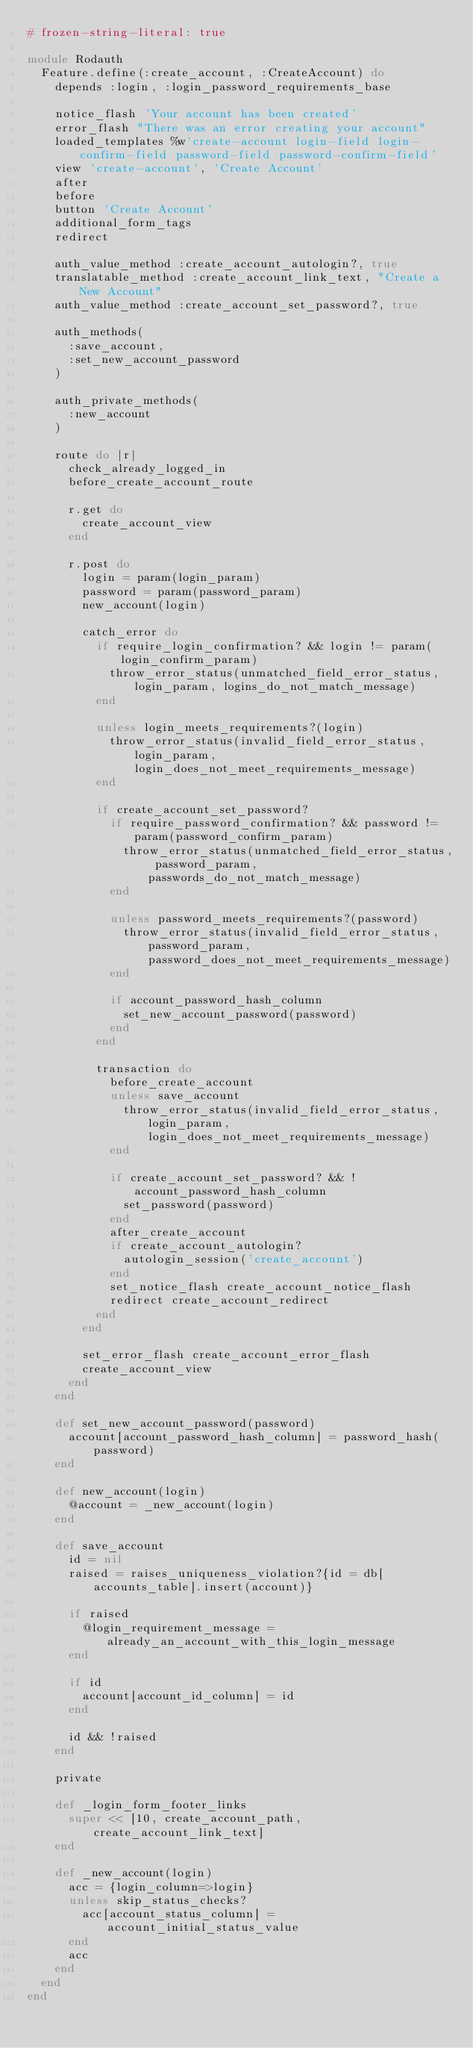Convert code to text. <code><loc_0><loc_0><loc_500><loc_500><_Ruby_># frozen-string-literal: true

module Rodauth
  Feature.define(:create_account, :CreateAccount) do
    depends :login, :login_password_requirements_base

    notice_flash 'Your account has been created'
    error_flash "There was an error creating your account"
    loaded_templates %w'create-account login-field login-confirm-field password-field password-confirm-field'
    view 'create-account', 'Create Account'
    after
    before
    button 'Create Account'
    additional_form_tags
    redirect

    auth_value_method :create_account_autologin?, true
    translatable_method :create_account_link_text, "Create a New Account"
    auth_value_method :create_account_set_password?, true

    auth_methods(
      :save_account,
      :set_new_account_password
    )

    auth_private_methods(
      :new_account
    )

    route do |r|
      check_already_logged_in
      before_create_account_route

      r.get do
        create_account_view
      end

      r.post do
        login = param(login_param)
        password = param(password_param)
        new_account(login)

        catch_error do
          if require_login_confirmation? && login != param(login_confirm_param)
            throw_error_status(unmatched_field_error_status, login_param, logins_do_not_match_message)
          end

          unless login_meets_requirements?(login)
            throw_error_status(invalid_field_error_status, login_param, login_does_not_meet_requirements_message)
          end

          if create_account_set_password?
            if require_password_confirmation? && password != param(password_confirm_param)
              throw_error_status(unmatched_field_error_status, password_param, passwords_do_not_match_message)
            end

            unless password_meets_requirements?(password)
              throw_error_status(invalid_field_error_status, password_param, password_does_not_meet_requirements_message)
            end

            if account_password_hash_column
              set_new_account_password(password)
            end
          end

          transaction do
            before_create_account
            unless save_account
              throw_error_status(invalid_field_error_status, login_param, login_does_not_meet_requirements_message)
            end

            if create_account_set_password? && !account_password_hash_column
              set_password(password)
            end
            after_create_account
            if create_account_autologin?
              autologin_session('create_account')
            end
            set_notice_flash create_account_notice_flash
            redirect create_account_redirect
          end
        end

        set_error_flash create_account_error_flash
        create_account_view
      end
    end

    def set_new_account_password(password)
      account[account_password_hash_column] = password_hash(password)
    end

    def new_account(login)
      @account = _new_account(login)
    end

    def save_account
      id = nil
      raised = raises_uniqueness_violation?{id = db[accounts_table].insert(account)}

      if raised
        @login_requirement_message = already_an_account_with_this_login_message
      end

      if id
        account[account_id_column] = id
      end

      id && !raised
    end

    private

    def _login_form_footer_links
      super << [10, create_account_path, create_account_link_text]
    end

    def _new_account(login)
      acc = {login_column=>login}
      unless skip_status_checks?
        acc[account_status_column] = account_initial_status_value
      end
      acc
    end
  end
end
</code> 